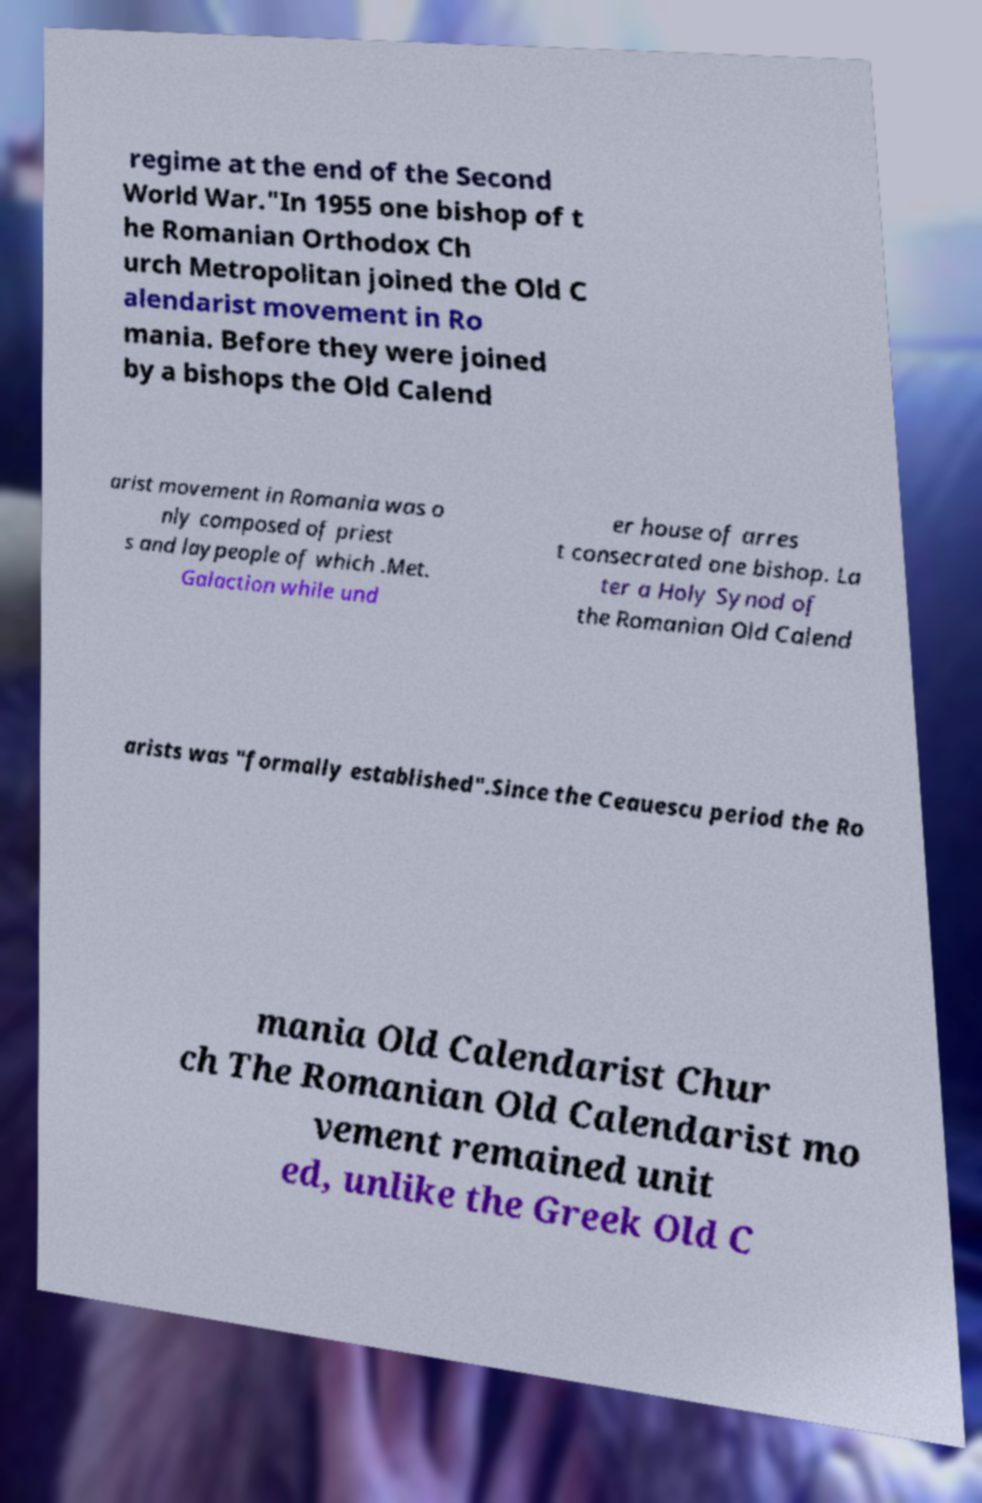Could you extract and type out the text from this image? regime at the end of the Second World War."In 1955 one bishop of t he Romanian Orthodox Ch urch Metropolitan joined the Old C alendarist movement in Ro mania. Before they were joined by a bishops the Old Calend arist movement in Romania was o nly composed of priest s and laypeople of which .Met. Galaction while und er house of arres t consecrated one bishop. La ter a Holy Synod of the Romanian Old Calend arists was "formally established".Since the Ceauescu period the Ro mania Old Calendarist Chur ch The Romanian Old Calendarist mo vement remained unit ed, unlike the Greek Old C 